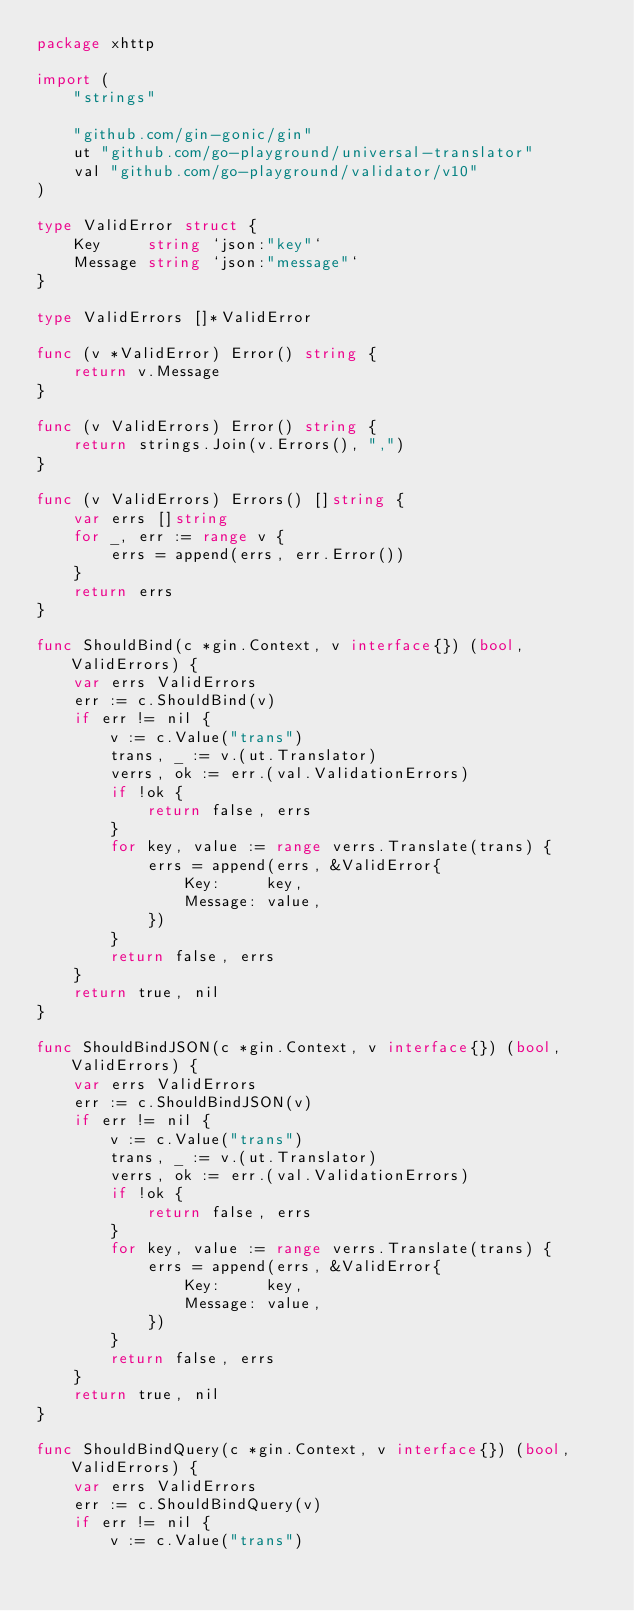Convert code to text. <code><loc_0><loc_0><loc_500><loc_500><_Go_>package xhttp

import (
	"strings"

	"github.com/gin-gonic/gin"
	ut "github.com/go-playground/universal-translator"
	val "github.com/go-playground/validator/v10"
)

type ValidError struct {
	Key     string `json:"key"`
	Message string `json:"message"`
}

type ValidErrors []*ValidError

func (v *ValidError) Error() string {
	return v.Message
}

func (v ValidErrors) Error() string {
	return strings.Join(v.Errors(), ",")
}

func (v ValidErrors) Errors() []string {
	var errs []string
	for _, err := range v {
		errs = append(errs, err.Error())
	}
	return errs
}

func ShouldBind(c *gin.Context, v interface{}) (bool, ValidErrors) {
	var errs ValidErrors
	err := c.ShouldBind(v)
	if err != nil {
		v := c.Value("trans")
		trans, _ := v.(ut.Translator)
		verrs, ok := err.(val.ValidationErrors)
		if !ok {
			return false, errs
		}
		for key, value := range verrs.Translate(trans) {
			errs = append(errs, &ValidError{
				Key:     key,
				Message: value,
			})
		}
		return false, errs
	}
	return true, nil
}

func ShouldBindJSON(c *gin.Context, v interface{}) (bool, ValidErrors) {
	var errs ValidErrors
	err := c.ShouldBindJSON(v)
	if err != nil {
		v := c.Value("trans")
		trans, _ := v.(ut.Translator)
		verrs, ok := err.(val.ValidationErrors)
		if !ok {
			return false, errs
		}
		for key, value := range verrs.Translate(trans) {
			errs = append(errs, &ValidError{
				Key:     key,
				Message: value,
			})
		}
		return false, errs
	}
	return true, nil
}

func ShouldBindQuery(c *gin.Context, v interface{}) (bool, ValidErrors) {
	var errs ValidErrors
	err := c.ShouldBindQuery(v)
	if err != nil {
		v := c.Value("trans")</code> 